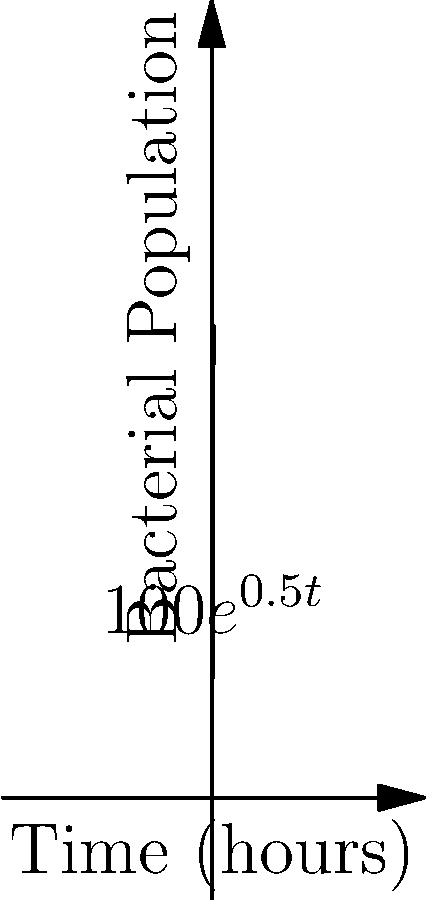A bacterial culture starts with 100 cells and grows exponentially according to the function $P(t) = 100e^{0.5t}$, where $P$ is the population and $t$ is time in hours. After how many hours will the bacterial population reach 1000 cells? To solve this problem, we need to follow these steps:

1) We are given the initial equation: $P(t) = 100e^{0.5t}$

2) We want to find $t$ when $P(t) = 1000$. So, let's set up the equation:
   
   $1000 = 100e^{0.5t}$

3) Divide both sides by 100:
   
   $10 = e^{0.5t}$

4) Take the natural logarithm of both sides:
   
   $\ln(10) = \ln(e^{0.5t})$

5) Simplify the right side using the property of logarithms:
   
   $\ln(10) = 0.5t$

6) Solve for $t$:
   
   $t = \frac{\ln(10)}{0.5} = 2\ln(10)$

7) Calculate the final value:
   
   $t \approx 4.605$ hours

Therefore, it will take approximately 4.605 hours for the bacterial population to reach 1000 cells.
Answer: $2\ln(10)$ hours (≈ 4.605 hours) 